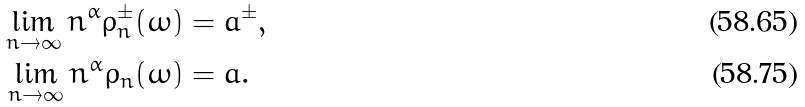<formula> <loc_0><loc_0><loc_500><loc_500>\lim _ { n \to \infty } n ^ { \alpha } \rho _ { n } ^ { \pm } ( \omega ) & = { a } ^ { \pm } , \\ \lim _ { n \to \infty } n ^ { \alpha } \rho _ { n } ( \omega ) & = a .</formula> 